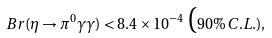Convert formula to latex. <formula><loc_0><loc_0><loc_500><loc_500>B r ( \eta \to \pi ^ { 0 } \gamma \gamma ) < 8 . 4 \times 1 0 ^ { - 4 } \, \mbox ( 9 0 \% \, C . L . ) ,</formula> 